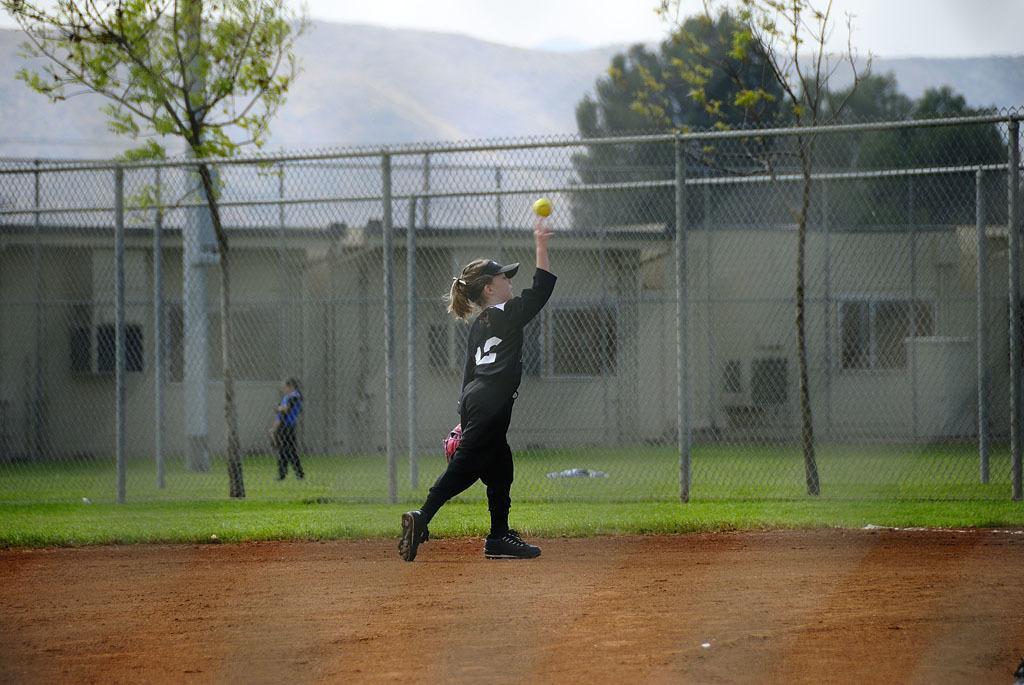Could you give a brief overview of what you see in this image? In the foreground of the image we can see a muddy ground. In the middle of the image we can see a girl is walking and catching a ball and some grass is there. On the top of the image we can see trees and the sky. 